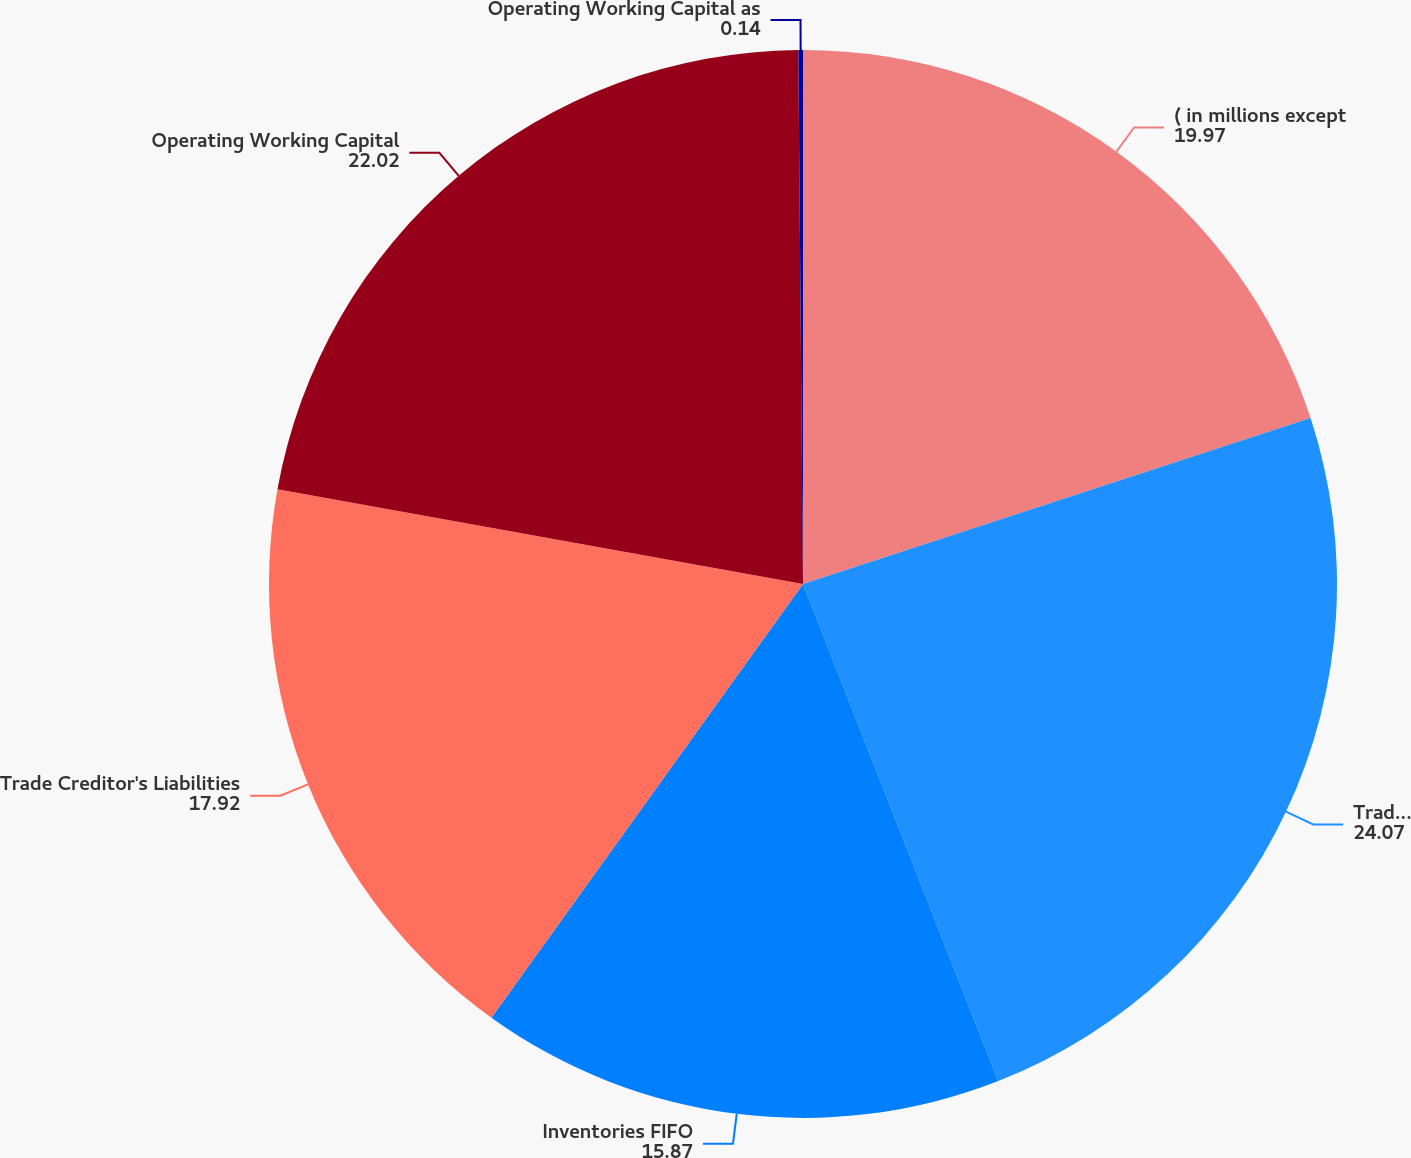Convert chart to OTSL. <chart><loc_0><loc_0><loc_500><loc_500><pie_chart><fcel>( in millions except<fcel>Trade Receivables net<fcel>Inventories FIFO<fcel>Trade Creditor's Liabilities<fcel>Operating Working Capital<fcel>Operating Working Capital as<nl><fcel>19.97%<fcel>24.07%<fcel>15.87%<fcel>17.92%<fcel>22.02%<fcel>0.14%<nl></chart> 